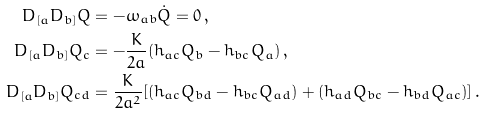Convert formula to latex. <formula><loc_0><loc_0><loc_500><loc_500>D _ { [ a } D _ { b ] } Q & = - \omega _ { a b } \dot { Q } = 0 \, , \\ D _ { [ a } D _ { b ] } Q _ { c } & = - \frac { K } { 2 a } ( h _ { a c } Q _ { b } - h _ { b c } Q _ { a } ) \, , \\ D _ { [ a } D _ { b ] } Q _ { c d } & = \frac { K } { 2 a ^ { 2 } } [ ( h _ { a c } Q _ { b d } - h _ { b c } Q _ { a d } ) + ( h _ { a d } Q _ { b c } - h _ { b d } Q _ { a c } ) ] \, .</formula> 